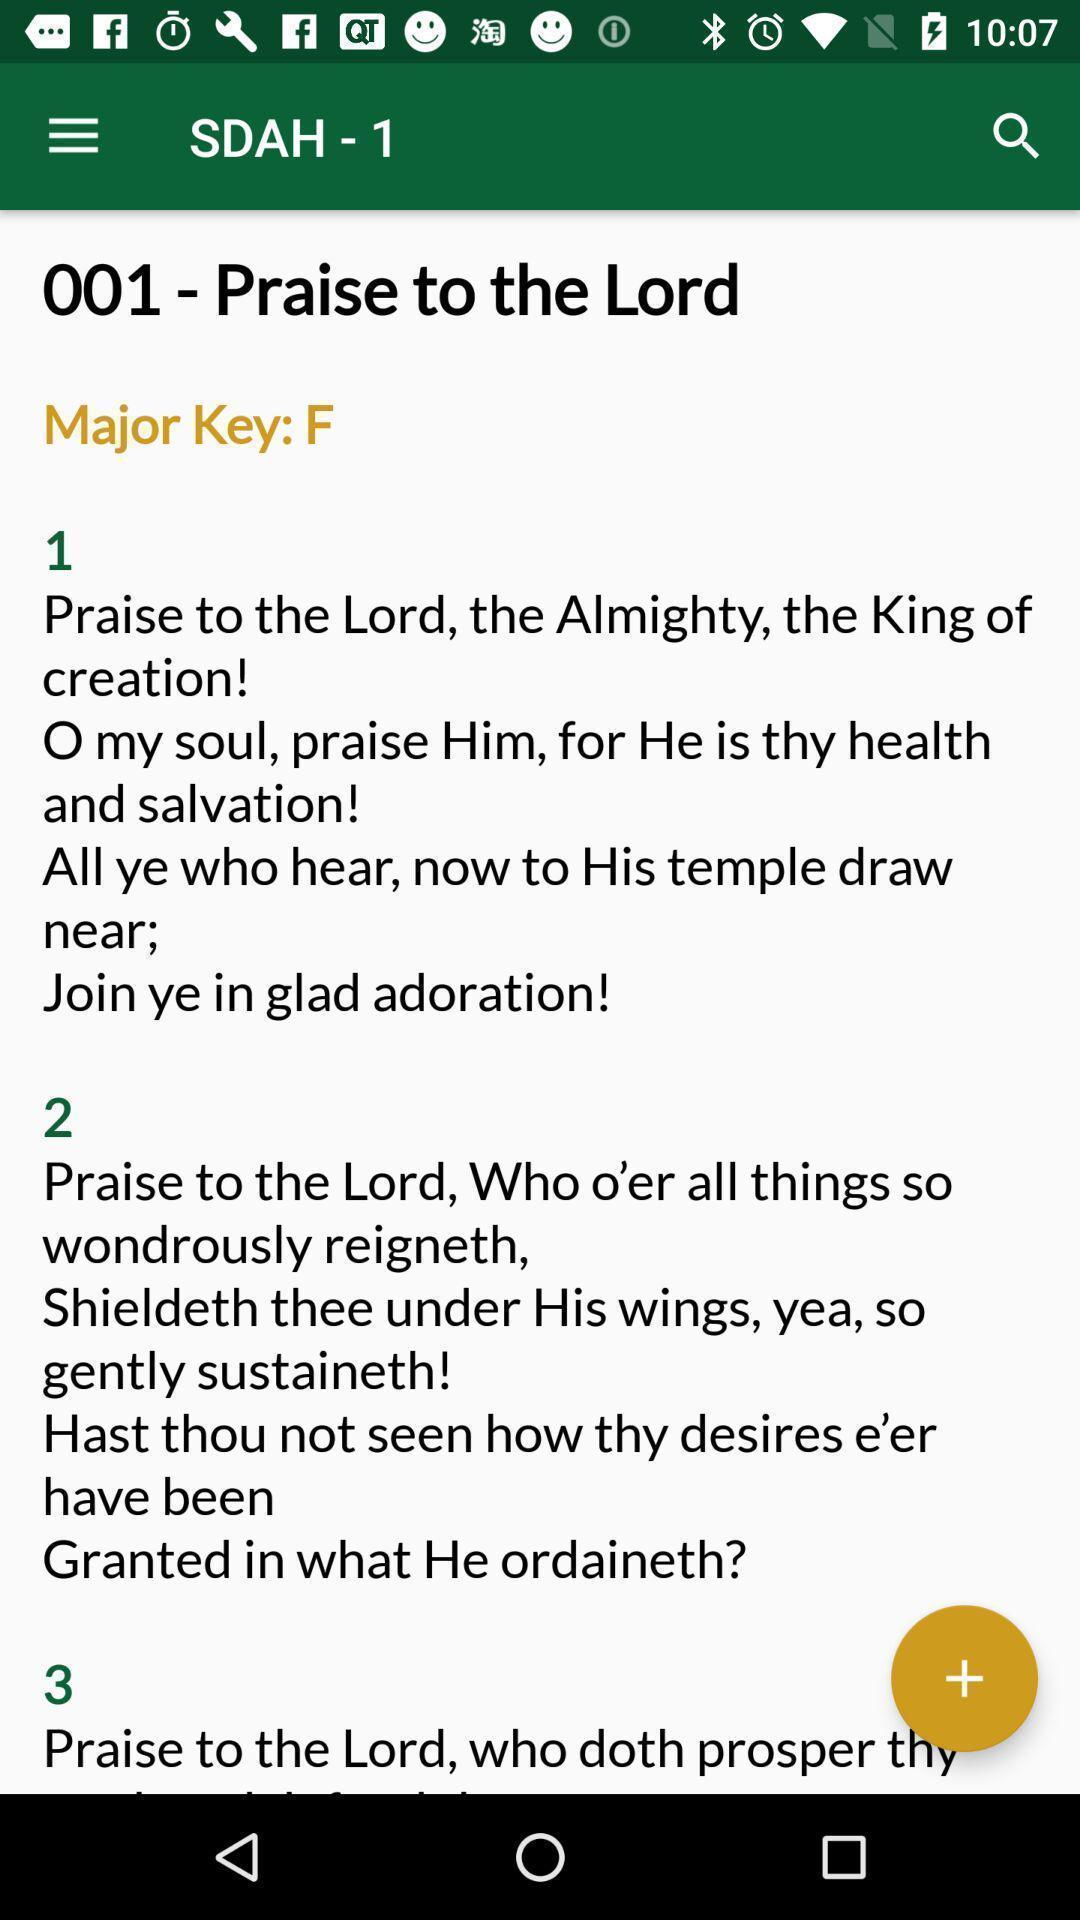What can you discern from this picture? Windows displaying hymns of bible. 